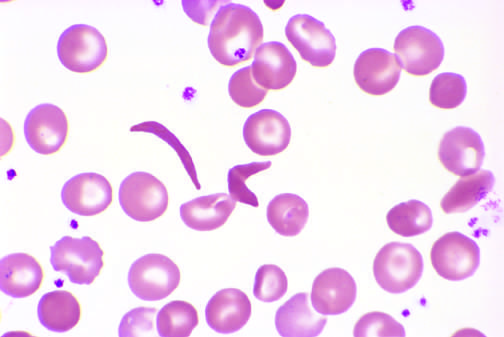what shows an irreversibly sickled cell in the center?
Answer the question using a single word or phrase. Higher magnification 